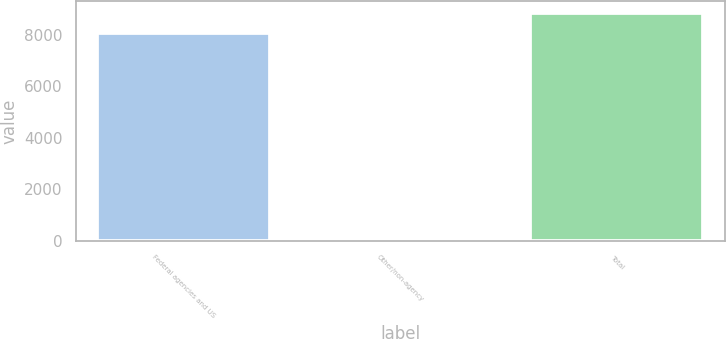<chart> <loc_0><loc_0><loc_500><loc_500><bar_chart><fcel>Federal agencies and US<fcel>Other/non-agency<fcel>Total<nl><fcel>8061<fcel>84<fcel>8867.1<nl></chart> 